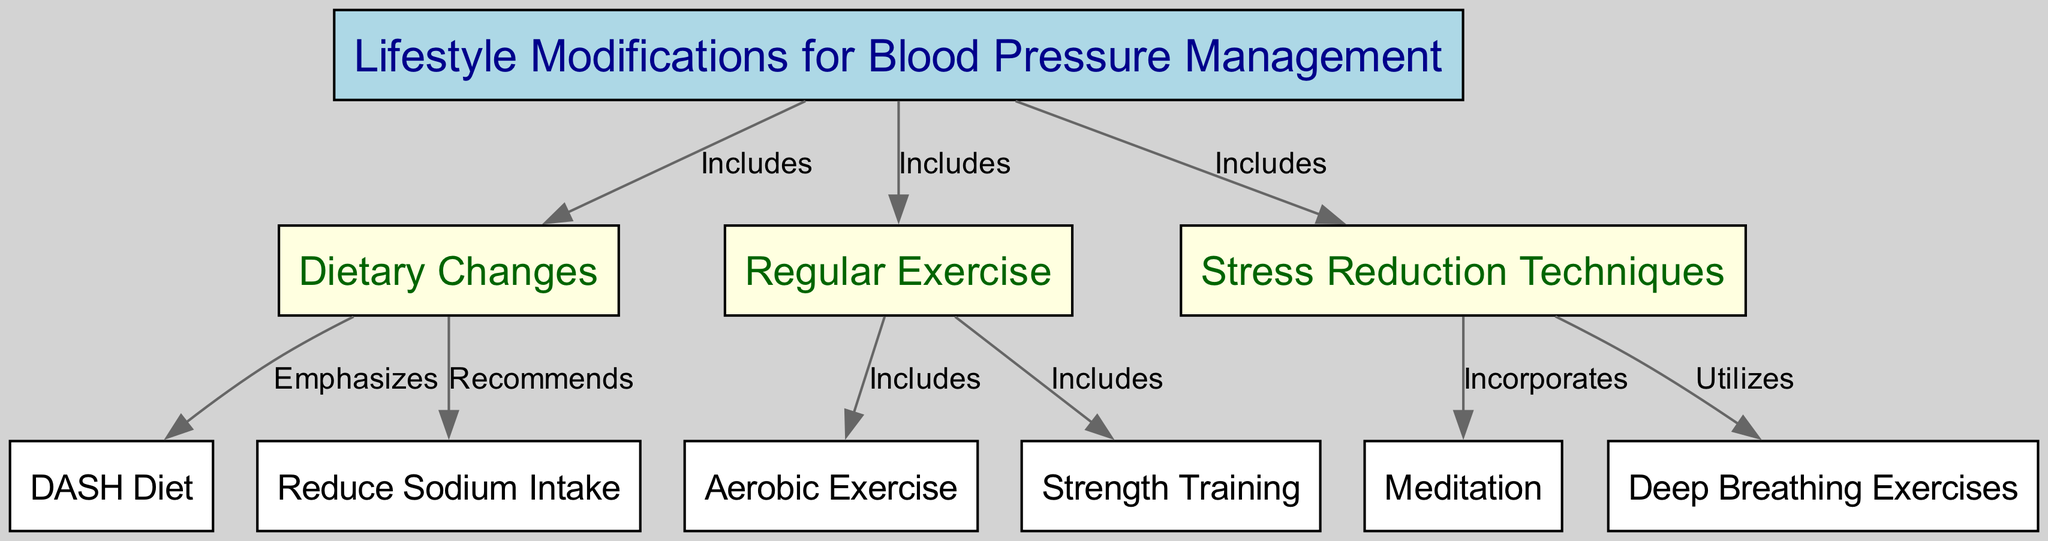What are the three main categories of lifestyle modifications for blood pressure management? The diagram shows that the three main categories are "Dietary Changes," "Regular Exercise," and "Stress Reduction Techniques."
Answer: Dietary Changes, Regular Exercise, Stress Reduction Techniques How many subcategories are under the category "Dietary Changes"? The diagram illustrates that "Dietary Changes" includes two subcategories: "DASH Diet" and "Reduce Sodium Intake."
Answer: 2 Which exercise type is specifically mentioned under "Regular Exercise"? The diagram lists "Aerobic Exercise" and "Strength Training" under the "Regular Exercise" category, but as the primary mention, I would focus on "Aerobic Exercise."
Answer: Aerobic Exercise What techniques are included in "Stress Reduction Techniques"? The diagram indicates two techniques under "Stress Reduction Techniques," which are "Meditation" and "Deep Breathing Exercises."
Answer: Meditation, Deep Breathing Exercises What is the relationship between "Dietary Changes" and "Reduce Sodium Intake"? The diagram shows that "Dietary Changes" recommends reducing sodium intake, creating a direct connection where this is an action taken under the dietary modifications for blood pressure management.
Answer: Recommends Which type of exercise does "Strength Training" fall under? According to the diagram, "Strength Training" is included in the category "Regular Exercise" that encompasses various forms of physical activity to help manage blood pressure.
Answer: Regular Exercise What label connects "Meditation" and "Stress Reduction Techniques"? The diagram states that "Meditation" is incorporated into "Stress Reduction Techniques," indicating a supportive relationship where meditation is a method used in this context.
Answer: Incorporates Is "DASH Diet" a specific approach under the broader category of "Diet"? The diagram clarifies that "DASH Diet" is emphasized under "Dietary Changes," confirming that it is a specific approach intended to help manage blood pressure.
Answer: Yes How many edges are there connecting nodes to "Lifestyle Modifications for Blood Pressure Management"? By examining the diagram, one can see that there are three edges leading from "Lifestyle Modifications" to "Dietary Changes," "Regular Exercise," and "Stress Reduction Techniques," thus totaling three connections.
Answer: 3 